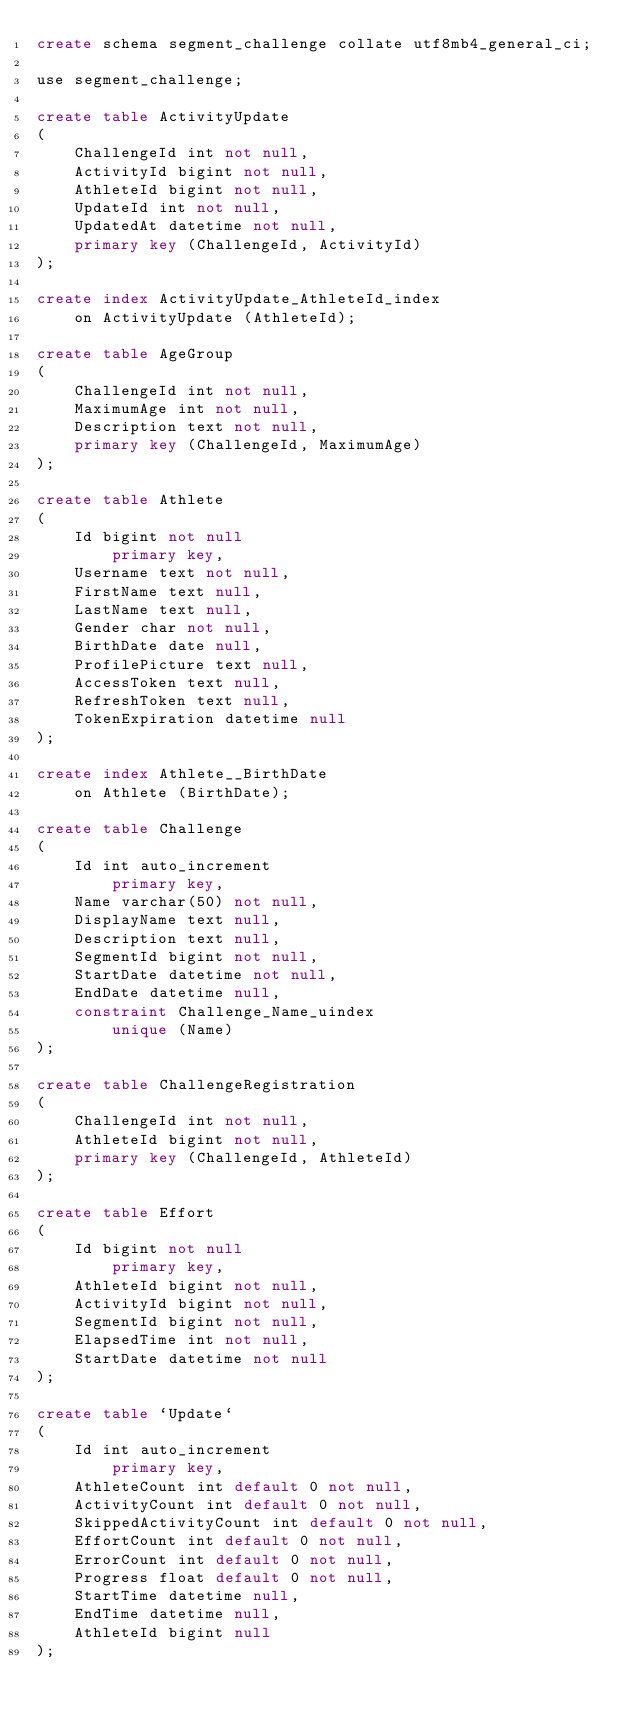<code> <loc_0><loc_0><loc_500><loc_500><_SQL_>create schema segment_challenge collate utf8mb4_general_ci;

use segment_challenge;

create table ActivityUpdate
(
    ChallengeId int not null,
    ActivityId bigint not null,
    AthleteId bigint not null,
    UpdateId int not null,
    UpdatedAt datetime not null,
    primary key (ChallengeId, ActivityId)
);

create index ActivityUpdate_AthleteId_index
    on ActivityUpdate (AthleteId);

create table AgeGroup
(
    ChallengeId int not null,
    MaximumAge int not null,
    Description text not null,
    primary key (ChallengeId, MaximumAge)
);

create table Athlete
(
    Id bigint not null
        primary key,
    Username text not null,
    FirstName text null,
    LastName text null,
    Gender char not null,
    BirthDate date null,
    ProfilePicture text null,
    AccessToken text null,
    RefreshToken text null,
    TokenExpiration datetime null
);

create index Athlete__BirthDate
    on Athlete (BirthDate);

create table Challenge
(
    Id int auto_increment
        primary key,
    Name varchar(50) not null,
    DisplayName text null,
    Description text null,
    SegmentId bigint not null,
    StartDate datetime not null,
    EndDate datetime null,
    constraint Challenge_Name_uindex
        unique (Name)
);

create table ChallengeRegistration
(
    ChallengeId int not null,
    AthleteId bigint not null,
    primary key (ChallengeId, AthleteId)
);

create table Effort
(
    Id bigint not null
        primary key,
    AthleteId bigint not null,
    ActivityId bigint not null,
    SegmentId bigint not null,
    ElapsedTime int not null,
    StartDate datetime not null
);

create table `Update`
(
    Id int auto_increment
        primary key,
    AthleteCount int default 0 not null,
    ActivityCount int default 0 not null,
    SkippedActivityCount int default 0 not null,
    EffortCount int default 0 not null,
    ErrorCount int default 0 not null,
    Progress float default 0 not null,
    StartTime datetime null,
    EndTime datetime null,
    AthleteId bigint null
);

</code> 